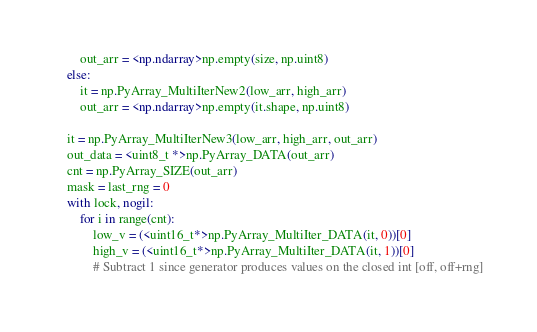Convert code to text. <code><loc_0><loc_0><loc_500><loc_500><_Cython_>        out_arr = <np.ndarray>np.empty(size, np.uint8)
    else:
        it = np.PyArray_MultiIterNew2(low_arr, high_arr)
        out_arr = <np.ndarray>np.empty(it.shape, np.uint8)

    it = np.PyArray_MultiIterNew3(low_arr, high_arr, out_arr)
    out_data = <uint8_t *>np.PyArray_DATA(out_arr)
    cnt = np.PyArray_SIZE(out_arr)
    mask = last_rng = 0
    with lock, nogil:
        for i in range(cnt):
            low_v = (<uint16_t*>np.PyArray_MultiIter_DATA(it, 0))[0]
            high_v = (<uint16_t*>np.PyArray_MultiIter_DATA(it, 1))[0]
            # Subtract 1 since generator produces values on the closed int [off, off+rng]</code> 